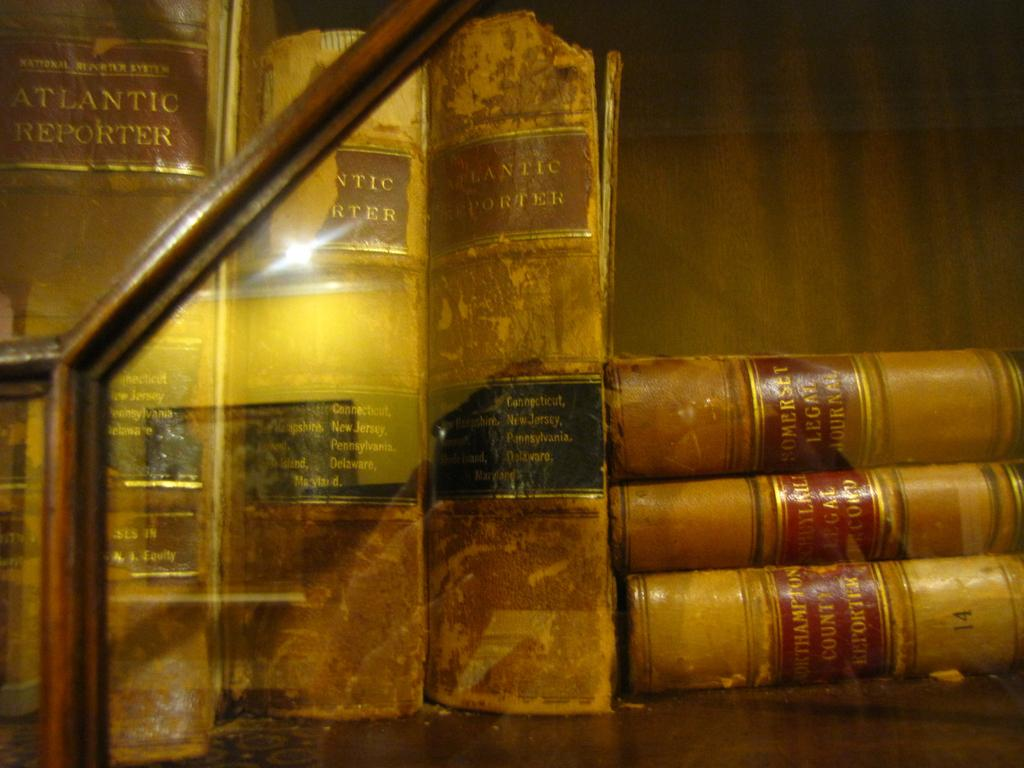What objects are visible on the surface in the image? There are books on the surface in the image. What might the books be used for? The books might be used for reading or studying. Can you describe the arrangement of the books on the surface? The arrangement of the books on the surface cannot be determined from the image alone. What color are the trousers worn by the hour in the image? There are no trousers or hours present in the image; it only features books on a surface. 